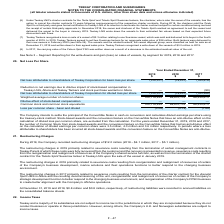According to Teekay Corporation's financial document, Which method is used for to settle the principal of the Convertible Notes in cash on conversion and calculates diluted earnings? the treasury-stock method. The document states: "n and calculates diluted earnings per share using the treasury-stock method. Stock-based awards and the conversion feature on the Convertible Notes th..." Also, What happens if a loss attributable to shareholders has been incurred? all stock-based awards and the conversion feature on the Convertible Notes are anti-dilutive.. The document states: "oss attributable to shareholders has been incurred all stock-based awards and the conversion feature on the Convertible Notes are anti-dilutive...." Also, What was the Convertible Notes that had an anti-dilutive effect on the calculation of diluted earnings per common share in the year end 2019, 2018 and 2017 respectively? The document contains multiple relevant values: 3.5 million, 4.0 million, 3.6 million. From the document: "ulation of diluted earnings per common share were 3.5 million, 4.0 million and 3.6 million respectively. In periods where a loss attributable to share..." Also, can you calculate: What is the change in Net loss attributable to shareholders of Teekay Corporation for basic loss per share from 2018 to 2019? Based on the calculation: 310,577-79,237, the result is 231340 (in thousands). This is based on the information: "y Corporation for basic loss per share (310,577) (79,237) (163,276) s of Teekay Corporation for basic loss per share (310,577) (79,237) (163,276)..." The key data points involved are: 310,577, 79,237. Also, can you calculate: What is the change in Weighted average number of common shares from 2018 to 2019? Based on the calculation: 100,719,224-99,670,176, the result is 1049048. This is based on the information: "ghted average number of common shares 100,719,224 99,670,176 86,335,473 Weighted average number of common shares 100,719,224 99,670,176 86,335,473..." The key data points involved are: 100,719,224, 99,670,176. Also, can you calculate: What is the change in Loss per common share - basic and diluted from 2018 to 2019? Based on the calculation: 3.08-0.79, the result is 2.29. This is based on the information: "Loss per common share - basic and diluted (3.08) (0.79) (1.89) Loss per common share - basic and diluted (3.08) (0.79) (1.89)..." The key data points involved are: 0.79, 3.08. 